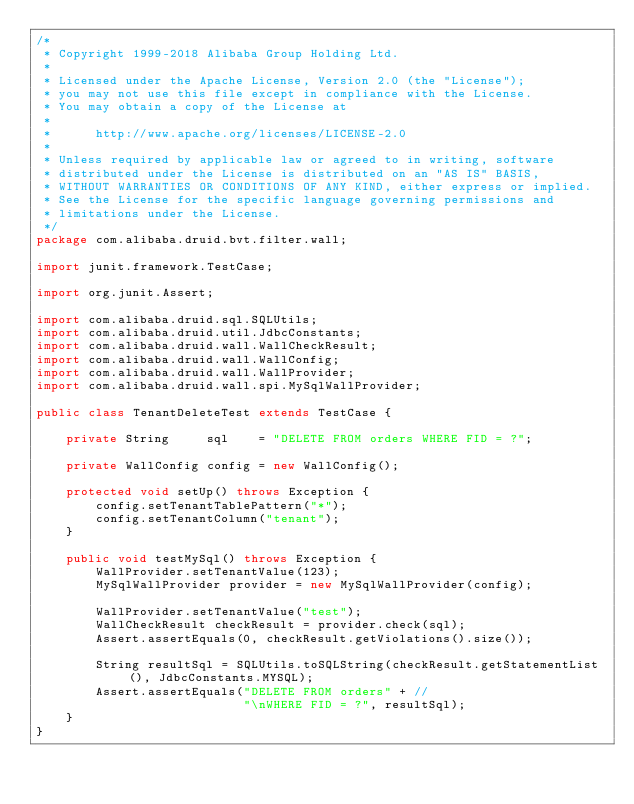<code> <loc_0><loc_0><loc_500><loc_500><_Java_>/*
 * Copyright 1999-2018 Alibaba Group Holding Ltd.
 *
 * Licensed under the Apache License, Version 2.0 (the "License");
 * you may not use this file except in compliance with the License.
 * You may obtain a copy of the License at
 *
 *      http://www.apache.org/licenses/LICENSE-2.0
 *
 * Unless required by applicable law or agreed to in writing, software
 * distributed under the License is distributed on an "AS IS" BASIS,
 * WITHOUT WARRANTIES OR CONDITIONS OF ANY KIND, either express or implied.
 * See the License for the specific language governing permissions and
 * limitations under the License.
 */
package com.alibaba.druid.bvt.filter.wall;

import junit.framework.TestCase;

import org.junit.Assert;

import com.alibaba.druid.sql.SQLUtils;
import com.alibaba.druid.util.JdbcConstants;
import com.alibaba.druid.wall.WallCheckResult;
import com.alibaba.druid.wall.WallConfig;
import com.alibaba.druid.wall.WallProvider;
import com.alibaba.druid.wall.spi.MySqlWallProvider;

public class TenantDeleteTest extends TestCase {

    private String     sql    = "DELETE FROM orders WHERE FID = ?";

    private WallConfig config = new WallConfig();

    protected void setUp() throws Exception {
        config.setTenantTablePattern("*");
        config.setTenantColumn("tenant");
    }

    public void testMySql() throws Exception {
        WallProvider.setTenantValue(123);
        MySqlWallProvider provider = new MySqlWallProvider(config);
        
        WallProvider.setTenantValue("test");
        WallCheckResult checkResult = provider.check(sql);
        Assert.assertEquals(0, checkResult.getViolations().size());

        String resultSql = SQLUtils.toSQLString(checkResult.getStatementList(), JdbcConstants.MYSQL);
        Assert.assertEquals("DELETE FROM orders" + //
                            "\nWHERE FID = ?", resultSql);
    }
}
</code> 